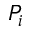<formula> <loc_0><loc_0><loc_500><loc_500>P _ { i }</formula> 